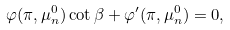<formula> <loc_0><loc_0><loc_500><loc_500>\varphi ( \pi , \mu _ { n } ^ { 0 } ) \cot \beta + \varphi ^ { \prime } ( \pi , \mu _ { n } ^ { 0 } ) = 0 ,</formula> 